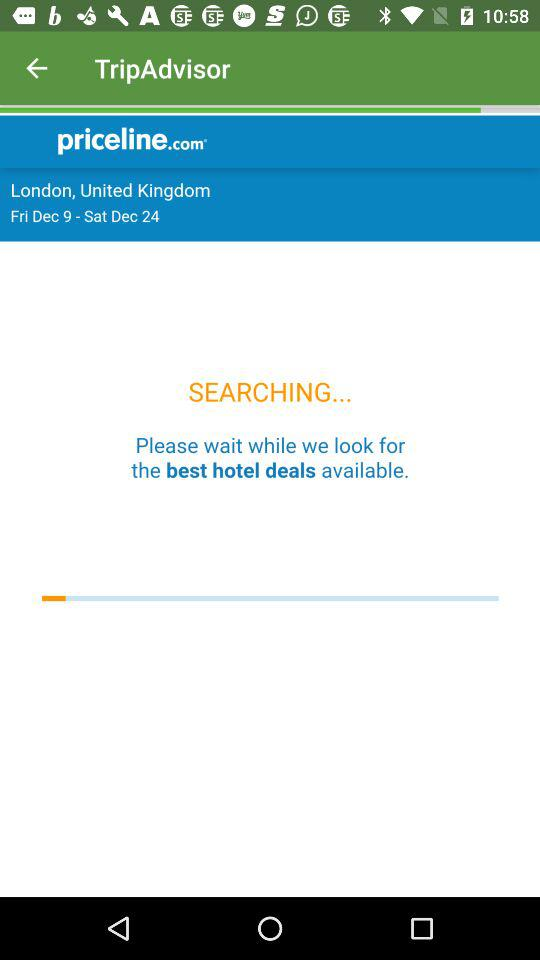For what date is the trip scheduled? The trip is scheduled from Friday, December 9 to Saturday, December 24. 